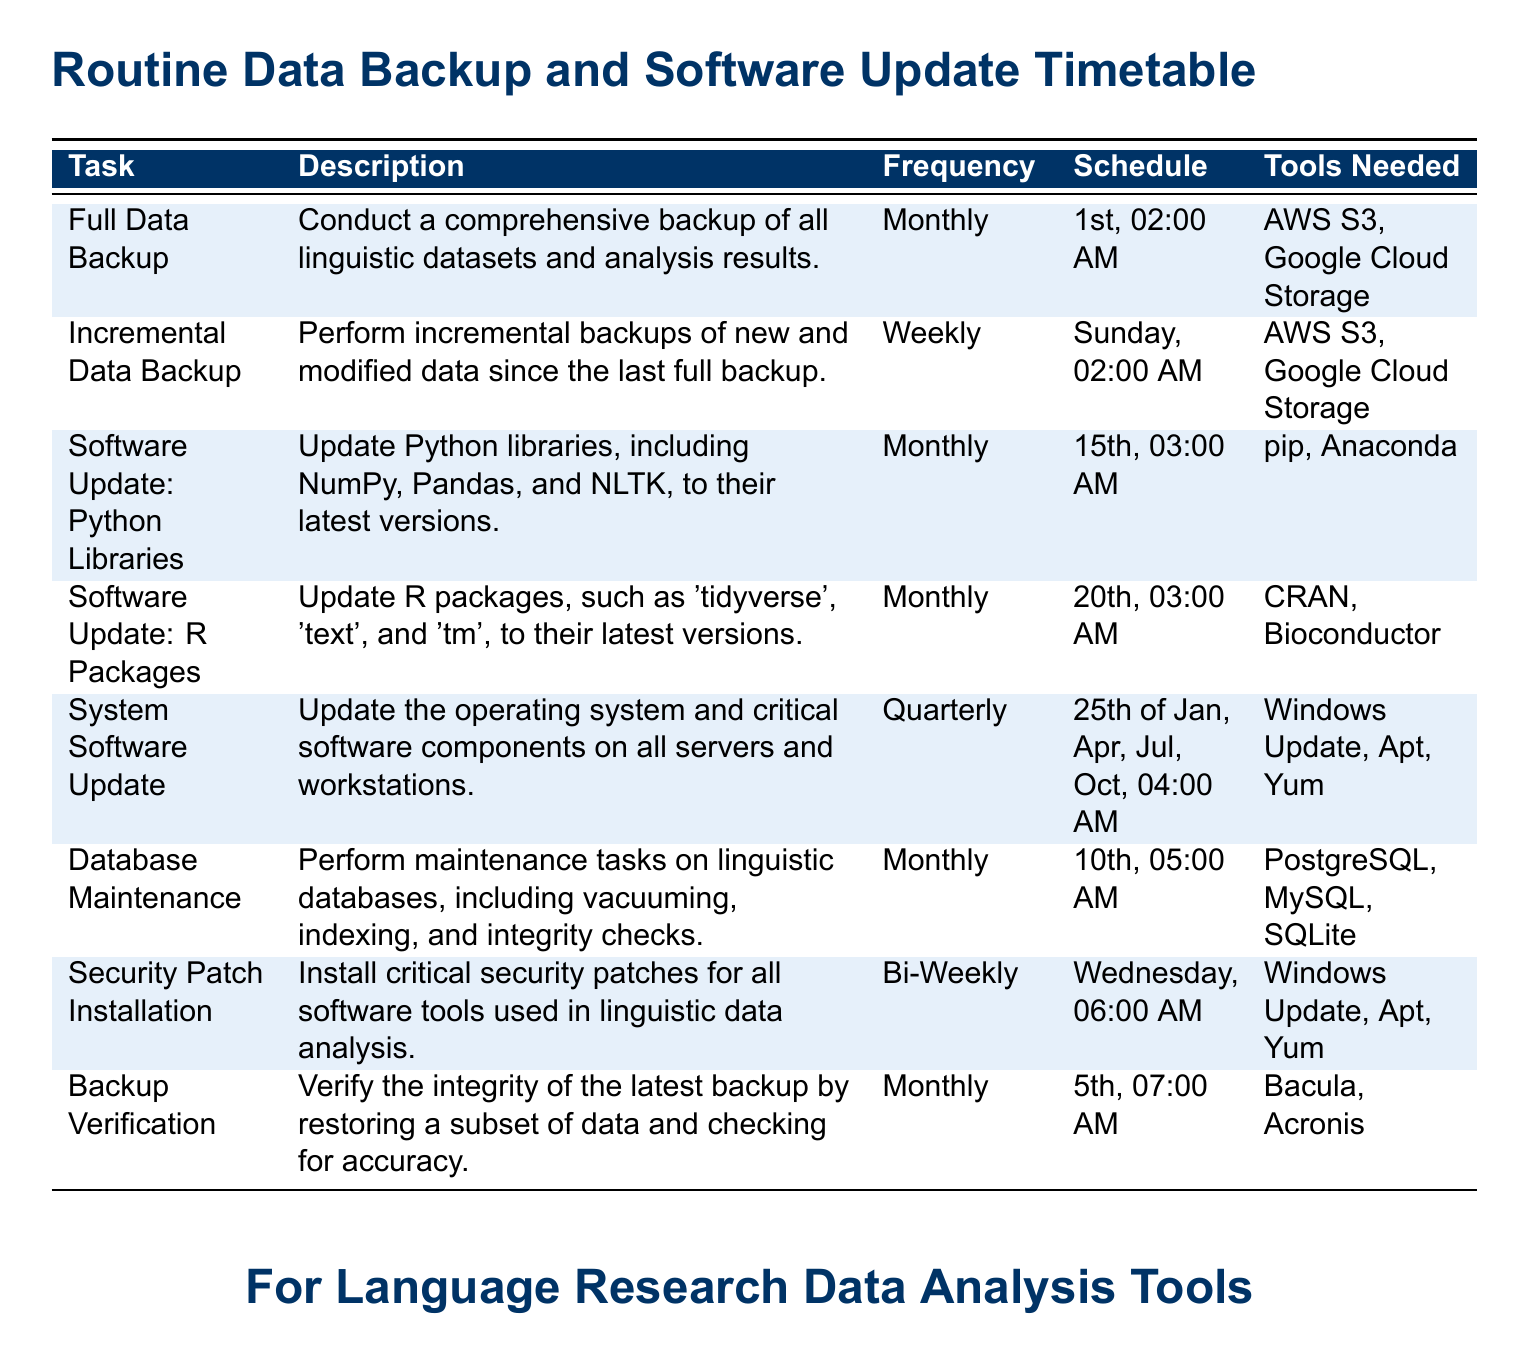What is the frequency of the Full Data Backup? The frequency is specified in the document as "Monthly".
Answer: Monthly On what day and time is the Incremental Data Backup scheduled? The schedule for the Incremental Data Backup is stated as "Sunday, 02:00 AM".
Answer: Sunday, 02:00 AM What tool is used for Software Update of Python Libraries? The document mentions "pip" and "Anaconda" as the tools needed for this update.
Answer: pip, Anaconda How often is the System Software updated? The frequency for System Software Update is "Quarterly".
Answer: Quarterly When is the Backup Verification performed? The document lists the Backup Verification as being scheduled for the "5th, 07:00 AM".
Answer: 5th, 07:00 AM What is the main purpose of the Security Patch Installation? The purpose is described as "Install critical security patches for all software tools used in linguistic data analysis".
Answer: Install critical security patches If a month has five Sundays, how many Incremental Data Backups will occur? Since the Incremental Data Backup is performed weekly, there would be five backups in a month with five Sundays.
Answer: 5 Which month does the quarterly System Software Update occur? The document specifies the months for updates as January, April, July, and October.
Answer: January, April, July, October What kind of tasks does Database Maintenance include? The tasks include "vacuuming, indexing, and integrity checks".
Answer: vacuuming, indexing, and integrity checks 